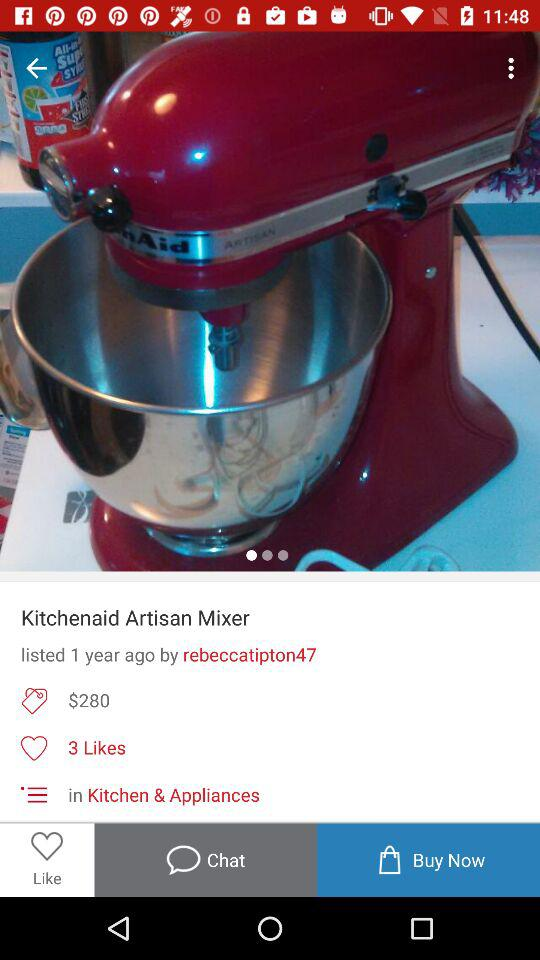How many years ago was this product listed? This product was listed 1 year ago. 